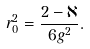<formula> <loc_0><loc_0><loc_500><loc_500>r _ { 0 } ^ { 2 } = \frac { 2 - \aleph } { 6 g ^ { 2 } } .</formula> 